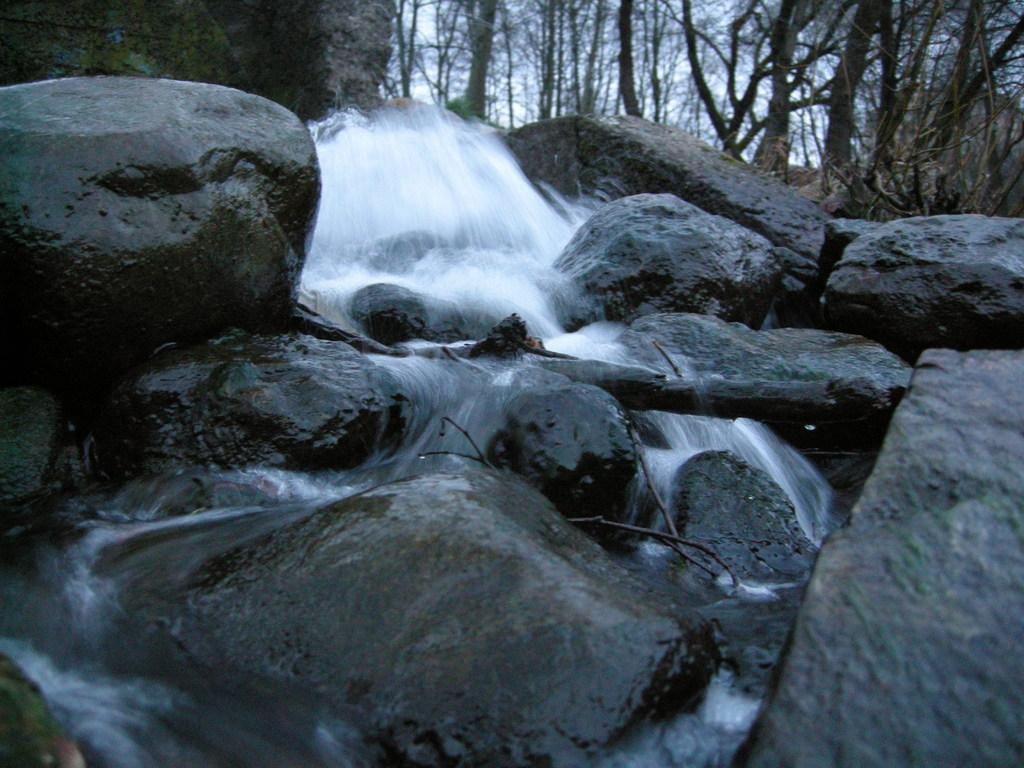Describe this image in one or two sentences. As we can see in the image there are rocks, water, trees and sky. 